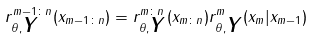<formula> <loc_0><loc_0><loc_500><loc_500>r _ { \theta , \boldsymbol Y } ^ { m - 1 \colon n } ( x _ { m - 1 \colon n } ) = r _ { \theta , \boldsymbol Y } ^ { m \colon n } ( x _ { m \colon n } ) r _ { \theta , \boldsymbol Y } ^ { m } ( x _ { m } | x _ { m - 1 } )</formula> 